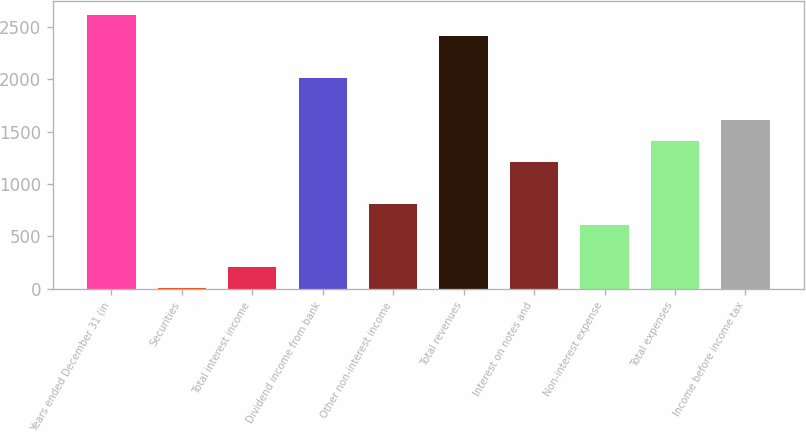Convert chart to OTSL. <chart><loc_0><loc_0><loc_500><loc_500><bar_chart><fcel>Years ended December 31 (in<fcel>Securities<fcel>Total interest income<fcel>Dividend income from bank<fcel>Other non-interest income<fcel>Total revenues<fcel>Interest on notes and<fcel>Non-interest expense<fcel>Total expenses<fcel>Income before income tax<nl><fcel>2619.78<fcel>3.4<fcel>204.66<fcel>2016<fcel>808.44<fcel>2418.52<fcel>1210.96<fcel>607.18<fcel>1412.22<fcel>1613.48<nl></chart> 